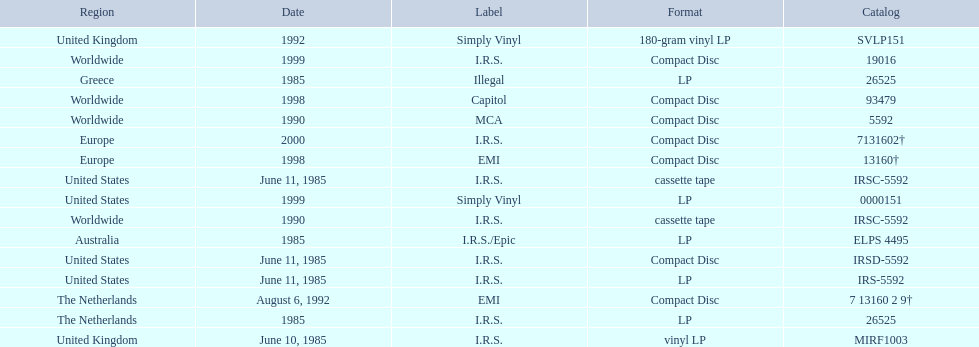In which regions was the fables of the reconstruction album released? United Kingdom, United States, United States, United States, Greece, Australia, The Netherlands, Worldwide, Worldwide, The Netherlands, United Kingdom, Worldwide, Europe, Worldwide, United States, Europe. And what were the release dates for those regions? June 10, 1985, June 11, 1985, June 11, 1985, June 11, 1985, 1985, 1985, 1985, 1990, 1990, August 6, 1992, 1992, 1998, 1998, 1999, 1999, 2000. And which region was listed after greece in 1985? Australia. 